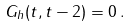<formula> <loc_0><loc_0><loc_500><loc_500>G _ { h } ( t , t - 2 ) = 0 \, .</formula> 